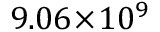Convert formula to latex. <formula><loc_0><loc_0><loc_500><loc_500>9 . 0 6 \, \times \, 1 0 ^ { 9 }</formula> 